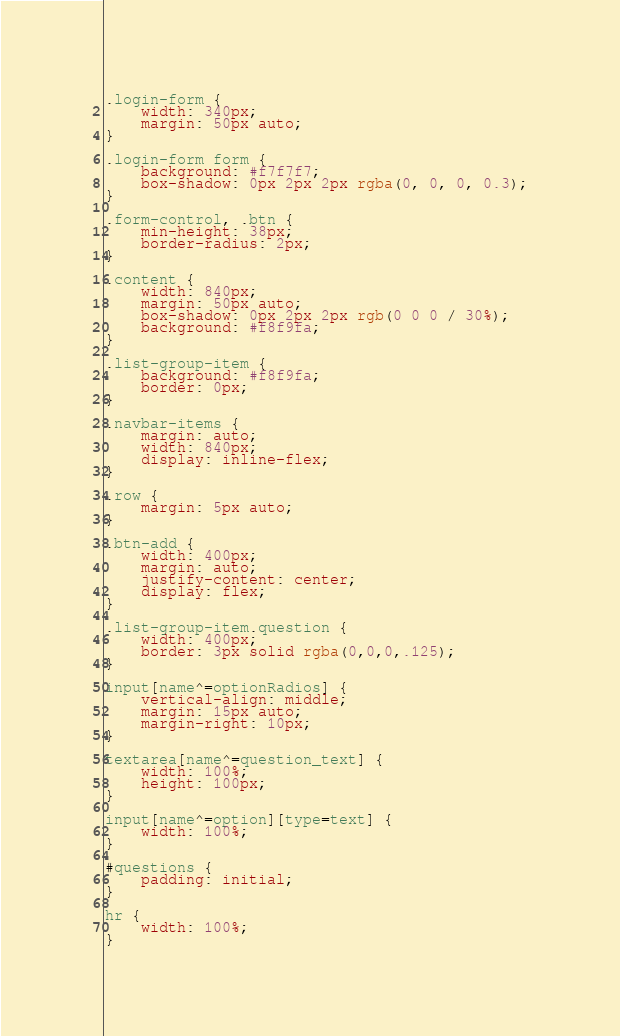Convert code to text. <code><loc_0><loc_0><loc_500><loc_500><_CSS_>.login-form {
    width: 340px;
    margin: 50px auto;
}

.login-form form {
    background: #f7f7f7;
    box-shadow: 0px 2px 2px rgba(0, 0, 0, 0.3);
}

.form-control, .btn {
    min-height: 38px;
    border-radius: 2px;
}

.content {
    width: 840px;
    margin: 50px auto;
    box-shadow: 0px 2px 2px rgb(0 0 0 / 30%);
    background: #f8f9fa;
}

.list-group-item {
    background: #f8f9fa;
    border: 0px;
}

.navbar-items {
    margin: auto;
    width: 840px;
    display: inline-flex;
}

.row {
    margin: 5px auto;
}

.btn-add {
    width: 400px;
    margin: auto;
    justify-content: center;
    display: flex;
}

.list-group-item.question {
    width: 400px;
    border: 3px solid rgba(0,0,0,.125);
}

input[name^=optionRadios] {
    vertical-align: middle;
    margin: 15px auto;
    margin-right: 10px;
}

textarea[name^=question_text] {
    width: 100%;
    height: 100px;
}

input[name^=option][type=text] {
    width: 100%;
}

#questions {
    padding: initial;
}

hr {
    width: 100%;
}</code> 